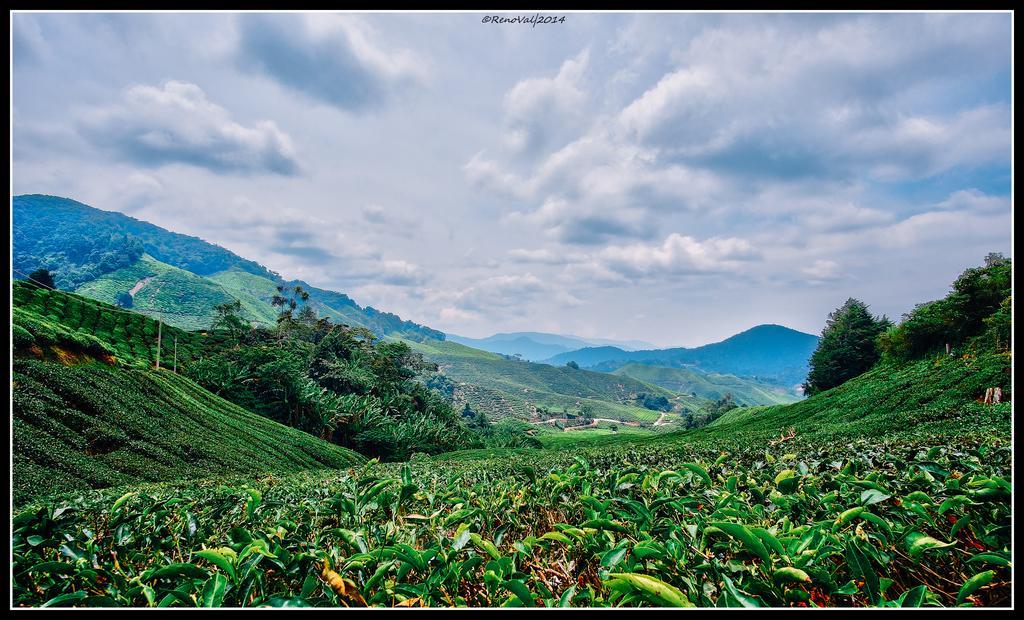How would you summarize this image in a sentence or two? In this image I can see few plants and trees in green color. In the background I can see the mountains and the sky is in blue and white color. 